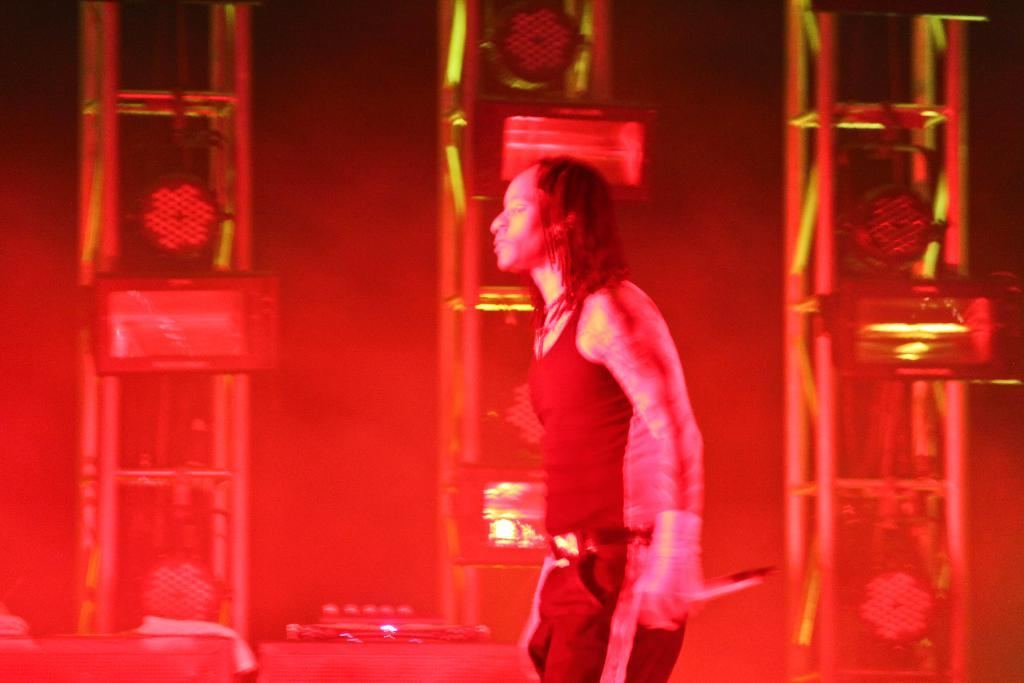What is the man in the image doing? The man is standing in the image and holding a microphone. Where is the microphone located in relation to the man? The microphone is at the bottom of the image. What can be seen in the background of the image? There are pillars in the background of the image. How many chairs are visible in the image? There are no chairs visible in the image. 